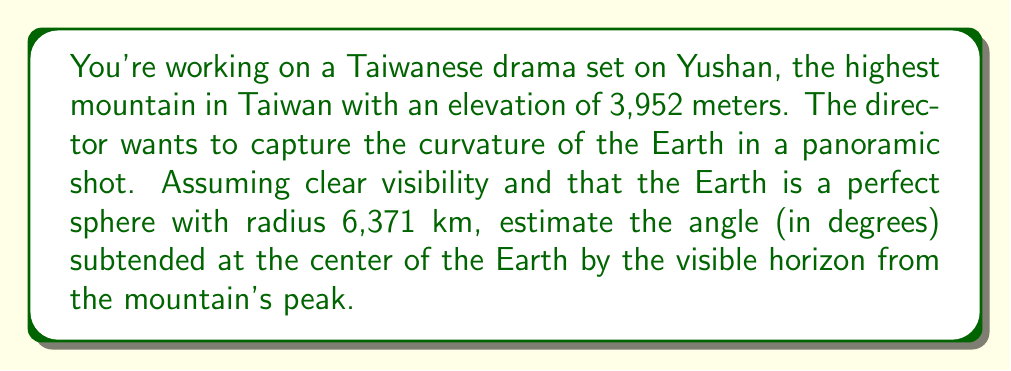Can you solve this math problem? Let's approach this step-by-step:

1) First, we need to visualize the problem. We have a right-angled triangle where:
   - The hypotenuse is the radius of the Earth (R) plus the height of the mountain (h)
   - One side is the radius of the Earth (R)
   - The other side is the distance to the horizon (d)

2) We can represent this using the Pythagorean theorem:

   $$(R+h)^2 = R^2 + d^2$$

3) Let's substitute the known values:
   R = 6,371 km
   h = 3.952 km (converted from meters)

4) Expanding the equation:

   $$R^2 + 2Rh + h^2 = R^2 + d^2$$

5) Simplifying:

   $$2Rh + h^2 = d^2$$

6) Substituting the values:

   $$2(6371)(3.952) + 3.952^2 = d^2$$

7) Solving for d:

   $$d \approx 224.83 \text{ km}$$

8) Now, to find the angle θ subtended at the center of the Earth:

   $$\cos(\theta) = \frac{R}{R+h} = \frac{6371}{6371 + 3.952} \approx 0.99938$$

9) Taking the inverse cosine:

   $$\theta = \arccos(0.99938) \approx 0.03508 \text{ radians}$$

10) Converting to degrees:

    $$\theta \approx 0.03508 \times \frac{180}{\pi} \approx 2.01°$$
Answer: $2.01°$ 